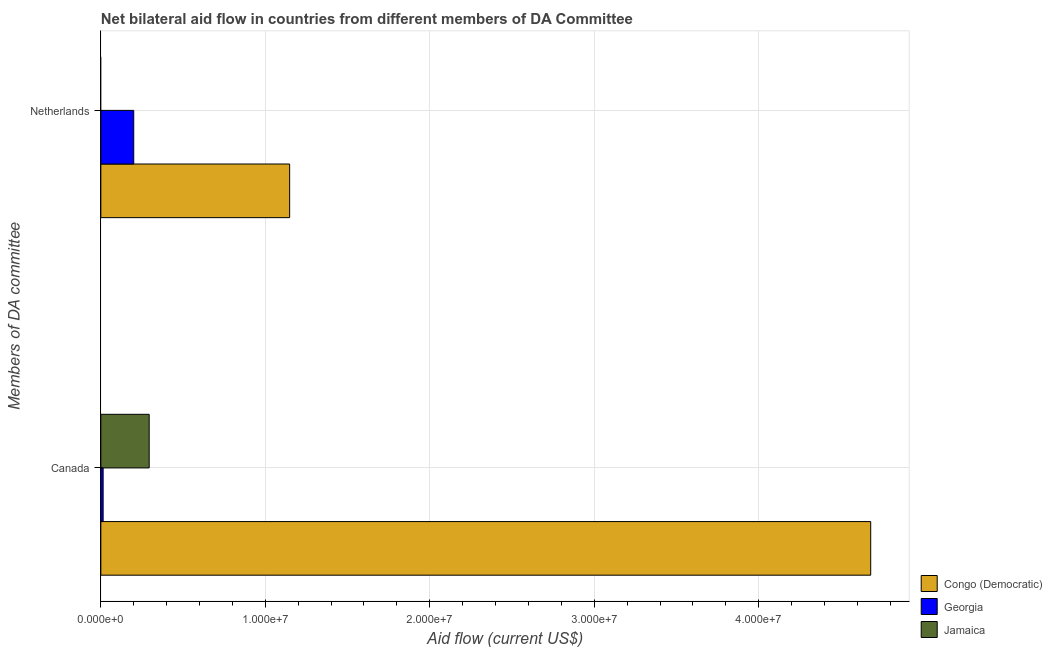How many different coloured bars are there?
Your response must be concise. 3. Are the number of bars per tick equal to the number of legend labels?
Your answer should be compact. No. How many bars are there on the 2nd tick from the top?
Keep it short and to the point. 3. How many bars are there on the 1st tick from the bottom?
Offer a very short reply. 3. What is the amount of aid given by canada in Congo (Democratic)?
Your response must be concise. 4.68e+07. Across all countries, what is the maximum amount of aid given by canada?
Your response must be concise. 4.68e+07. Across all countries, what is the minimum amount of aid given by netherlands?
Ensure brevity in your answer.  0. In which country was the amount of aid given by canada maximum?
Provide a short and direct response. Congo (Democratic). What is the total amount of aid given by netherlands in the graph?
Ensure brevity in your answer.  1.35e+07. What is the difference between the amount of aid given by canada in Georgia and that in Jamaica?
Give a very brief answer. -2.80e+06. What is the difference between the amount of aid given by netherlands in Georgia and the amount of aid given by canada in Jamaica?
Your answer should be compact. -9.40e+05. What is the average amount of aid given by netherlands per country?
Your answer should be compact. 4.49e+06. What is the difference between the amount of aid given by canada and amount of aid given by netherlands in Congo (Democratic)?
Your answer should be compact. 3.53e+07. In how many countries, is the amount of aid given by canada greater than 22000000 US$?
Provide a short and direct response. 1. What is the ratio of the amount of aid given by canada in Jamaica to that in Congo (Democratic)?
Keep it short and to the point. 0.06. How many legend labels are there?
Your answer should be compact. 3. What is the title of the graph?
Your response must be concise. Net bilateral aid flow in countries from different members of DA Committee. What is the label or title of the X-axis?
Offer a very short reply. Aid flow (current US$). What is the label or title of the Y-axis?
Provide a short and direct response. Members of DA committee. What is the Aid flow (current US$) of Congo (Democratic) in Canada?
Give a very brief answer. 4.68e+07. What is the Aid flow (current US$) in Georgia in Canada?
Offer a very short reply. 1.40e+05. What is the Aid flow (current US$) in Jamaica in Canada?
Provide a short and direct response. 2.94e+06. What is the Aid flow (current US$) in Congo (Democratic) in Netherlands?
Give a very brief answer. 1.15e+07. What is the Aid flow (current US$) of Jamaica in Netherlands?
Ensure brevity in your answer.  0. Across all Members of DA committee, what is the maximum Aid flow (current US$) of Congo (Democratic)?
Your answer should be compact. 4.68e+07. Across all Members of DA committee, what is the maximum Aid flow (current US$) of Georgia?
Offer a very short reply. 2.00e+06. Across all Members of DA committee, what is the maximum Aid flow (current US$) in Jamaica?
Your answer should be compact. 2.94e+06. Across all Members of DA committee, what is the minimum Aid flow (current US$) of Congo (Democratic)?
Your answer should be very brief. 1.15e+07. Across all Members of DA committee, what is the minimum Aid flow (current US$) in Jamaica?
Give a very brief answer. 0. What is the total Aid flow (current US$) of Congo (Democratic) in the graph?
Keep it short and to the point. 5.83e+07. What is the total Aid flow (current US$) in Georgia in the graph?
Give a very brief answer. 2.14e+06. What is the total Aid flow (current US$) in Jamaica in the graph?
Keep it short and to the point. 2.94e+06. What is the difference between the Aid flow (current US$) of Congo (Democratic) in Canada and that in Netherlands?
Your response must be concise. 3.53e+07. What is the difference between the Aid flow (current US$) of Georgia in Canada and that in Netherlands?
Provide a succinct answer. -1.86e+06. What is the difference between the Aid flow (current US$) in Congo (Democratic) in Canada and the Aid flow (current US$) in Georgia in Netherlands?
Keep it short and to the point. 4.48e+07. What is the average Aid flow (current US$) in Congo (Democratic) per Members of DA committee?
Your answer should be very brief. 2.91e+07. What is the average Aid flow (current US$) in Georgia per Members of DA committee?
Your response must be concise. 1.07e+06. What is the average Aid flow (current US$) of Jamaica per Members of DA committee?
Make the answer very short. 1.47e+06. What is the difference between the Aid flow (current US$) of Congo (Democratic) and Aid flow (current US$) of Georgia in Canada?
Provide a succinct answer. 4.67e+07. What is the difference between the Aid flow (current US$) in Congo (Democratic) and Aid flow (current US$) in Jamaica in Canada?
Give a very brief answer. 4.39e+07. What is the difference between the Aid flow (current US$) in Georgia and Aid flow (current US$) in Jamaica in Canada?
Offer a very short reply. -2.80e+06. What is the difference between the Aid flow (current US$) in Congo (Democratic) and Aid flow (current US$) in Georgia in Netherlands?
Your response must be concise. 9.48e+06. What is the ratio of the Aid flow (current US$) of Congo (Democratic) in Canada to that in Netherlands?
Provide a succinct answer. 4.08. What is the ratio of the Aid flow (current US$) of Georgia in Canada to that in Netherlands?
Your answer should be compact. 0.07. What is the difference between the highest and the second highest Aid flow (current US$) of Congo (Democratic)?
Make the answer very short. 3.53e+07. What is the difference between the highest and the second highest Aid flow (current US$) of Georgia?
Offer a very short reply. 1.86e+06. What is the difference between the highest and the lowest Aid flow (current US$) in Congo (Democratic)?
Ensure brevity in your answer.  3.53e+07. What is the difference between the highest and the lowest Aid flow (current US$) of Georgia?
Keep it short and to the point. 1.86e+06. What is the difference between the highest and the lowest Aid flow (current US$) in Jamaica?
Your answer should be very brief. 2.94e+06. 